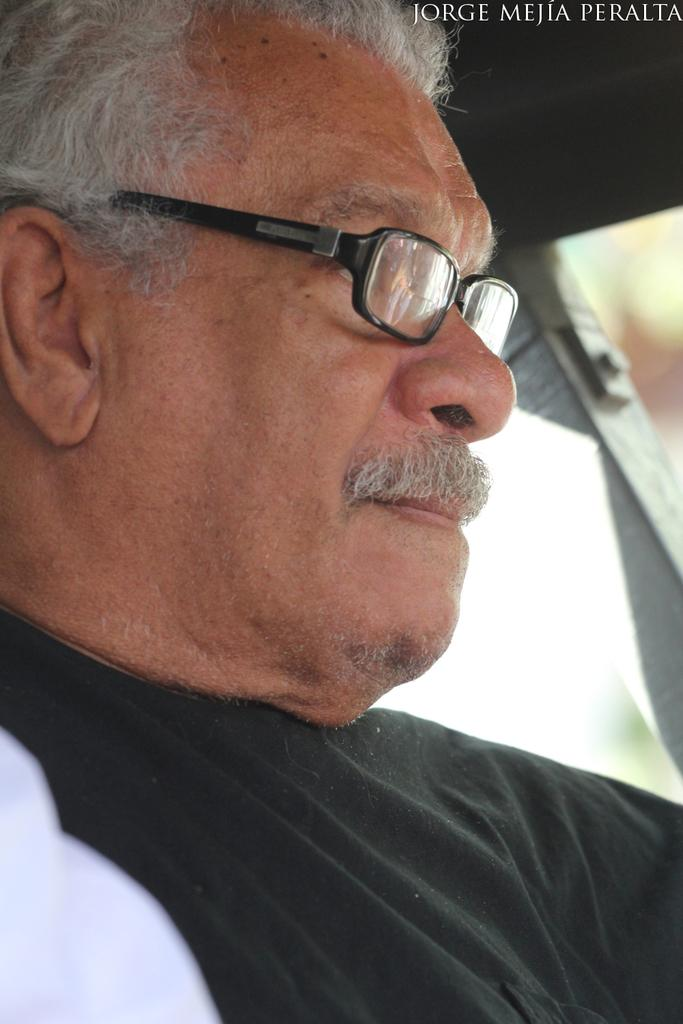What is present in the image? There is a person in the image. Can you describe the person's appearance? The person is wearing clothes and spectacles. What type of pancake is being used to destroy the pump in the image? There is no pancake or pump present in the image, and therefore no such activity can be observed. 